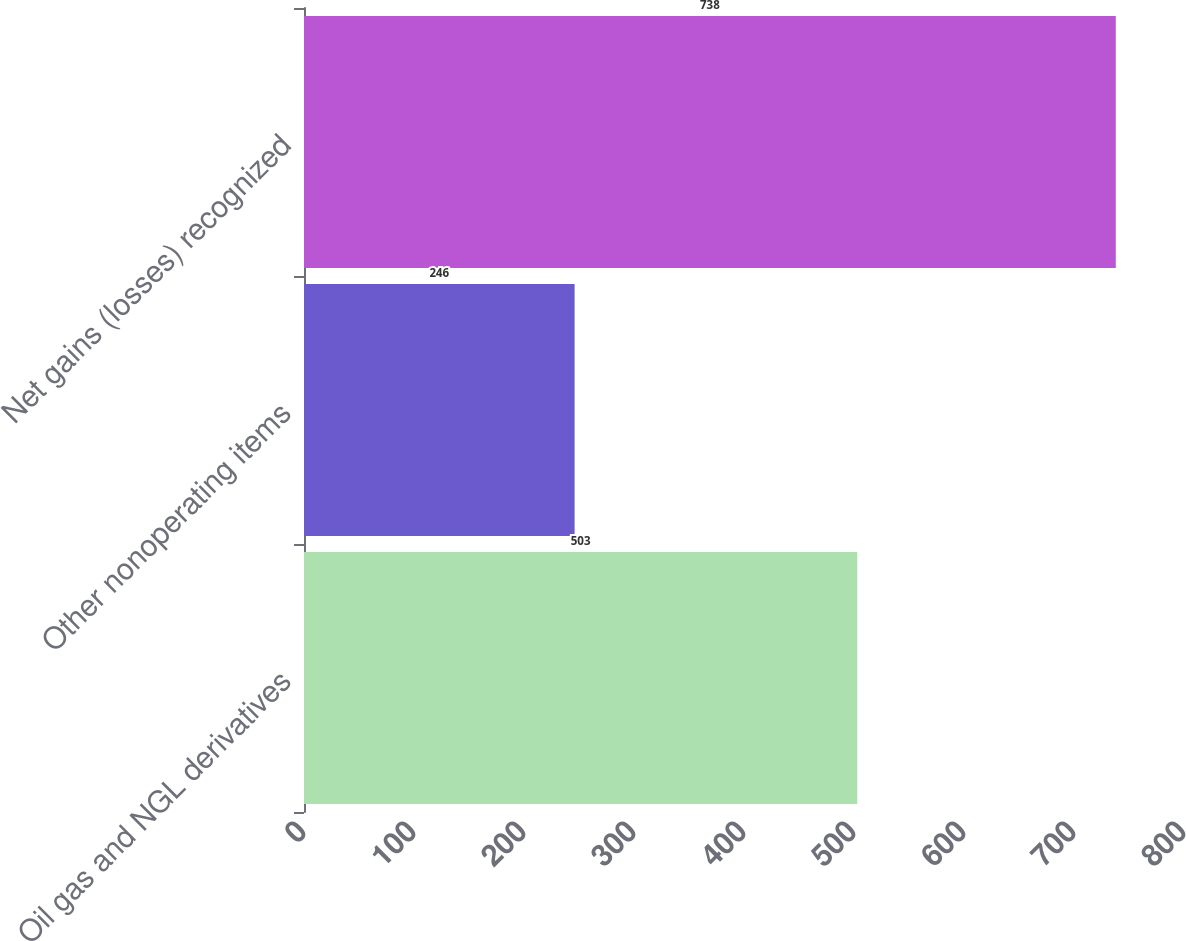Convert chart. <chart><loc_0><loc_0><loc_500><loc_500><bar_chart><fcel>Oil gas and NGL derivatives<fcel>Other nonoperating items<fcel>Net gains (losses) recognized<nl><fcel>503<fcel>246<fcel>738<nl></chart> 